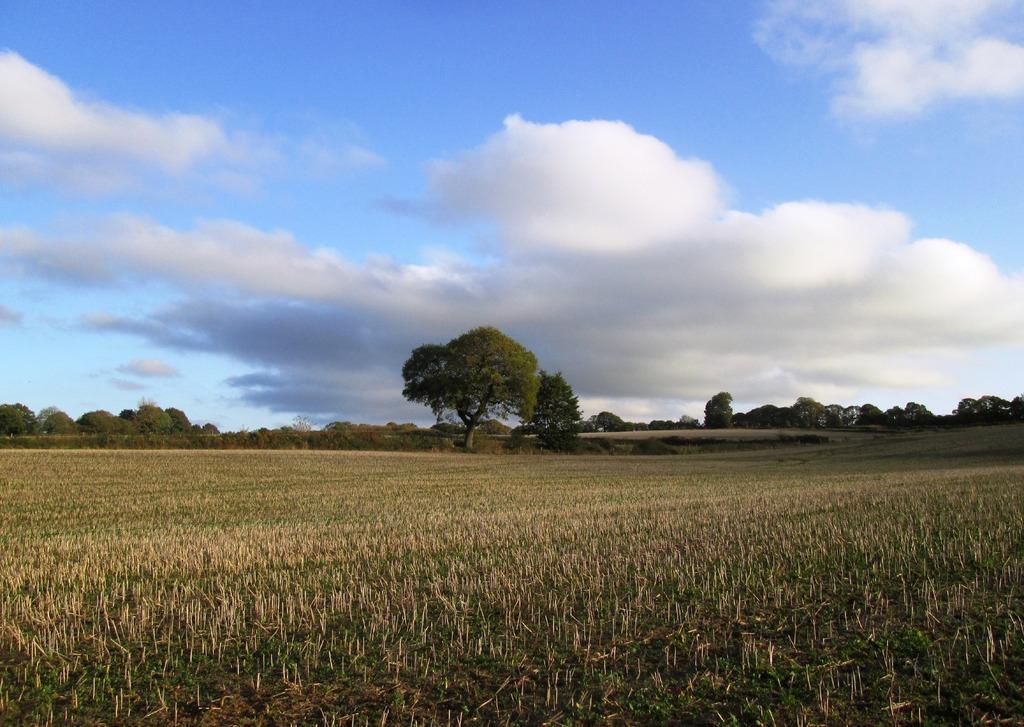Can you describe this image briefly? In the foreground of this image, there is a farming field. In the background, there are trees, sky and the cloud. 